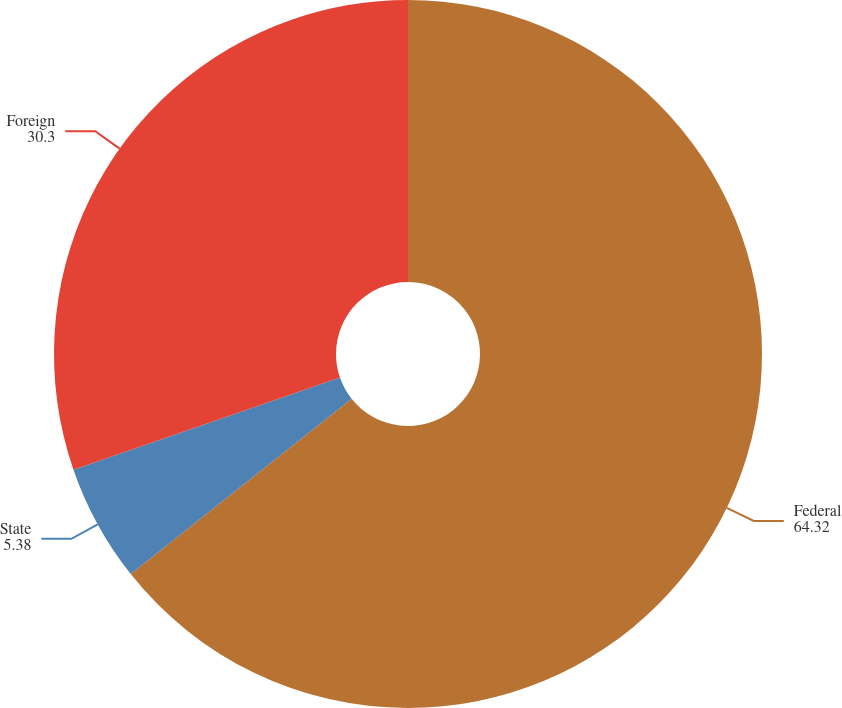Convert chart to OTSL. <chart><loc_0><loc_0><loc_500><loc_500><pie_chart><fcel>Federal<fcel>State<fcel>Foreign<nl><fcel>64.32%<fcel>5.38%<fcel>30.3%<nl></chart> 